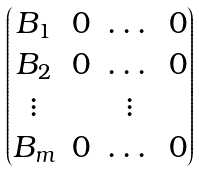<formula> <loc_0><loc_0><loc_500><loc_500>\begin{pmatrix} B _ { 1 } & 0 & \dots & 0 \\ B _ { 2 } & 0 & \dots & 0 \\ \vdots & & \vdots \\ B _ { m } & 0 & \dots & 0 \end{pmatrix}</formula> 